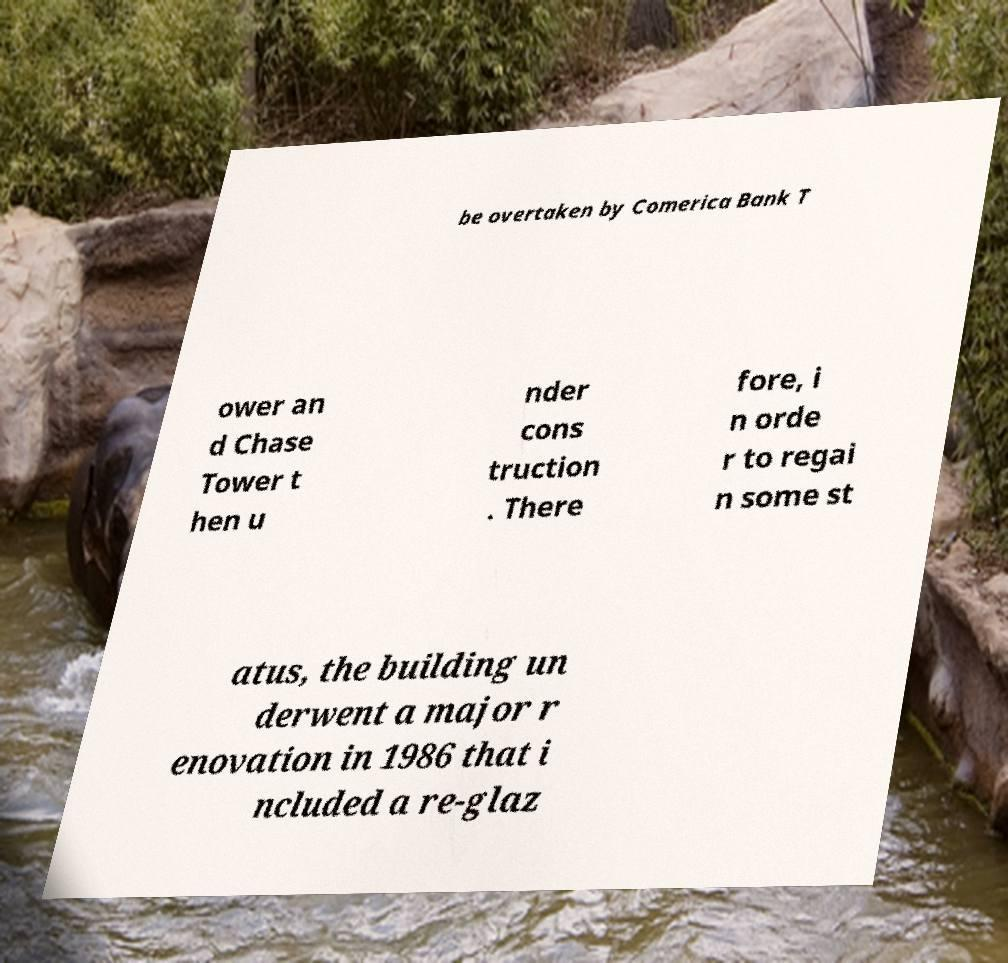There's text embedded in this image that I need extracted. Can you transcribe it verbatim? be overtaken by Comerica Bank T ower an d Chase Tower t hen u nder cons truction . There fore, i n orde r to regai n some st atus, the building un derwent a major r enovation in 1986 that i ncluded a re-glaz 